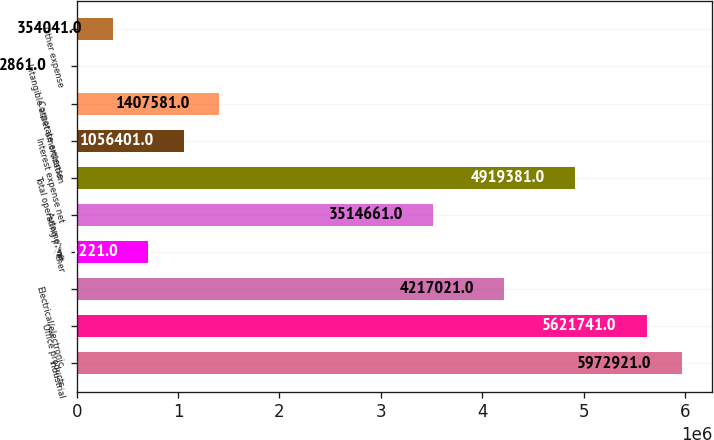Convert chart to OTSL. <chart><loc_0><loc_0><loc_500><loc_500><bar_chart><fcel>Industrial<fcel>Office products<fcel>Electrical/electronic<fcel>Other<fcel>Automotive<fcel>Total operating profit<fcel>Interest expense net<fcel>Corporate expense<fcel>Intangible asset amortization<fcel>Other expense<nl><fcel>5.97292e+06<fcel>5.62174e+06<fcel>4.21702e+06<fcel>705221<fcel>3.51466e+06<fcel>4.91938e+06<fcel>1.0564e+06<fcel>1.40758e+06<fcel>2861<fcel>354041<nl></chart> 